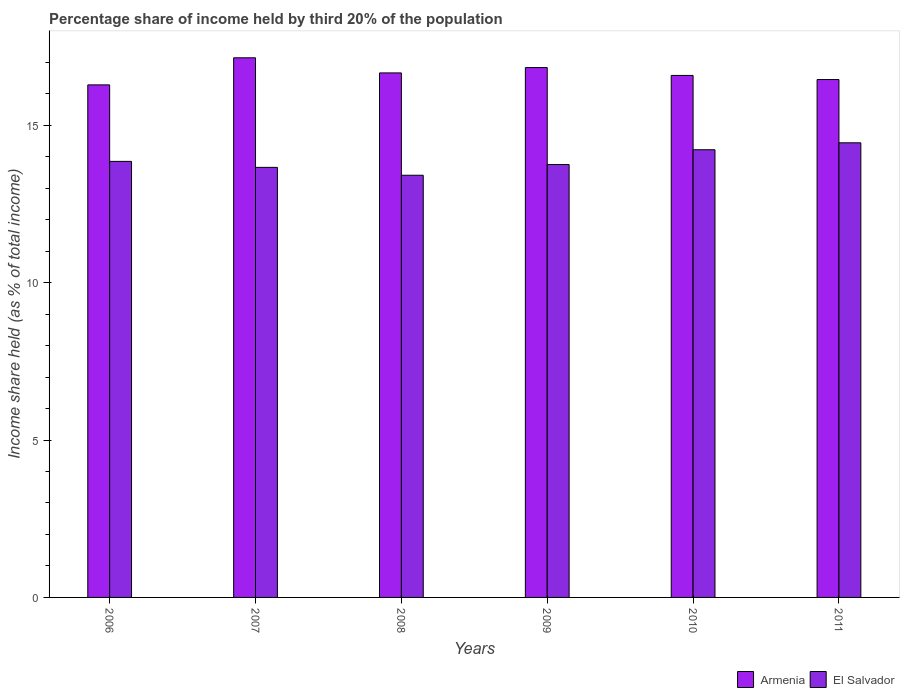Are the number of bars on each tick of the X-axis equal?
Provide a succinct answer. Yes. How many bars are there on the 4th tick from the left?
Provide a succinct answer. 2. How many bars are there on the 6th tick from the right?
Make the answer very short. 2. What is the label of the 1st group of bars from the left?
Give a very brief answer. 2006. In how many cases, is the number of bars for a given year not equal to the number of legend labels?
Keep it short and to the point. 0. What is the share of income held by third 20% of the population in El Salvador in 2010?
Make the answer very short. 14.22. Across all years, what is the maximum share of income held by third 20% of the population in El Salvador?
Ensure brevity in your answer.  14.44. Across all years, what is the minimum share of income held by third 20% of the population in El Salvador?
Your response must be concise. 13.41. In which year was the share of income held by third 20% of the population in El Salvador maximum?
Your answer should be compact. 2011. In which year was the share of income held by third 20% of the population in Armenia minimum?
Your response must be concise. 2006. What is the total share of income held by third 20% of the population in El Salvador in the graph?
Your response must be concise. 83.33. What is the difference between the share of income held by third 20% of the population in Armenia in 2008 and that in 2009?
Provide a short and direct response. -0.17. What is the difference between the share of income held by third 20% of the population in Armenia in 2008 and the share of income held by third 20% of the population in El Salvador in 2006?
Provide a short and direct response. 2.81. What is the average share of income held by third 20% of the population in Armenia per year?
Ensure brevity in your answer.  16.66. In the year 2007, what is the difference between the share of income held by third 20% of the population in Armenia and share of income held by third 20% of the population in El Salvador?
Provide a short and direct response. 3.48. What is the ratio of the share of income held by third 20% of the population in Armenia in 2008 to that in 2009?
Ensure brevity in your answer.  0.99. Is the share of income held by third 20% of the population in Armenia in 2007 less than that in 2008?
Keep it short and to the point. No. Is the difference between the share of income held by third 20% of the population in Armenia in 2006 and 2011 greater than the difference between the share of income held by third 20% of the population in El Salvador in 2006 and 2011?
Your answer should be compact. Yes. What is the difference between the highest and the second highest share of income held by third 20% of the population in El Salvador?
Give a very brief answer. 0.22. What is the difference between the highest and the lowest share of income held by third 20% of the population in El Salvador?
Your answer should be very brief. 1.03. In how many years, is the share of income held by third 20% of the population in El Salvador greater than the average share of income held by third 20% of the population in El Salvador taken over all years?
Your response must be concise. 2. Is the sum of the share of income held by third 20% of the population in Armenia in 2006 and 2007 greater than the maximum share of income held by third 20% of the population in El Salvador across all years?
Your response must be concise. Yes. What does the 1st bar from the left in 2011 represents?
Ensure brevity in your answer.  Armenia. What does the 2nd bar from the right in 2009 represents?
Your answer should be compact. Armenia. How many bars are there?
Offer a very short reply. 12. Are all the bars in the graph horizontal?
Ensure brevity in your answer.  No. How many years are there in the graph?
Your answer should be very brief. 6. What is the difference between two consecutive major ticks on the Y-axis?
Your answer should be very brief. 5. Does the graph contain any zero values?
Make the answer very short. No. How many legend labels are there?
Offer a terse response. 2. How are the legend labels stacked?
Your answer should be compact. Horizontal. What is the title of the graph?
Give a very brief answer. Percentage share of income held by third 20% of the population. Does "Virgin Islands" appear as one of the legend labels in the graph?
Offer a terse response. No. What is the label or title of the X-axis?
Your response must be concise. Years. What is the label or title of the Y-axis?
Ensure brevity in your answer.  Income share held (as % of total income). What is the Income share held (as % of total income) in Armenia in 2006?
Offer a very short reply. 16.28. What is the Income share held (as % of total income) in El Salvador in 2006?
Your answer should be compact. 13.85. What is the Income share held (as % of total income) in Armenia in 2007?
Offer a terse response. 17.14. What is the Income share held (as % of total income) of El Salvador in 2007?
Your answer should be very brief. 13.66. What is the Income share held (as % of total income) in Armenia in 2008?
Ensure brevity in your answer.  16.66. What is the Income share held (as % of total income) of El Salvador in 2008?
Your answer should be compact. 13.41. What is the Income share held (as % of total income) of Armenia in 2009?
Give a very brief answer. 16.83. What is the Income share held (as % of total income) in El Salvador in 2009?
Provide a short and direct response. 13.75. What is the Income share held (as % of total income) in Armenia in 2010?
Offer a very short reply. 16.58. What is the Income share held (as % of total income) of El Salvador in 2010?
Your answer should be very brief. 14.22. What is the Income share held (as % of total income) of Armenia in 2011?
Keep it short and to the point. 16.45. What is the Income share held (as % of total income) of El Salvador in 2011?
Make the answer very short. 14.44. Across all years, what is the maximum Income share held (as % of total income) in Armenia?
Your answer should be very brief. 17.14. Across all years, what is the maximum Income share held (as % of total income) in El Salvador?
Provide a succinct answer. 14.44. Across all years, what is the minimum Income share held (as % of total income) of Armenia?
Offer a terse response. 16.28. Across all years, what is the minimum Income share held (as % of total income) in El Salvador?
Your response must be concise. 13.41. What is the total Income share held (as % of total income) in Armenia in the graph?
Provide a short and direct response. 99.94. What is the total Income share held (as % of total income) of El Salvador in the graph?
Provide a succinct answer. 83.33. What is the difference between the Income share held (as % of total income) in Armenia in 2006 and that in 2007?
Offer a very short reply. -0.86. What is the difference between the Income share held (as % of total income) of El Salvador in 2006 and that in 2007?
Give a very brief answer. 0.19. What is the difference between the Income share held (as % of total income) of Armenia in 2006 and that in 2008?
Provide a succinct answer. -0.38. What is the difference between the Income share held (as % of total income) of El Salvador in 2006 and that in 2008?
Give a very brief answer. 0.44. What is the difference between the Income share held (as % of total income) in Armenia in 2006 and that in 2009?
Your answer should be very brief. -0.55. What is the difference between the Income share held (as % of total income) of El Salvador in 2006 and that in 2009?
Your response must be concise. 0.1. What is the difference between the Income share held (as % of total income) in Armenia in 2006 and that in 2010?
Your response must be concise. -0.3. What is the difference between the Income share held (as % of total income) of El Salvador in 2006 and that in 2010?
Offer a terse response. -0.37. What is the difference between the Income share held (as % of total income) in Armenia in 2006 and that in 2011?
Make the answer very short. -0.17. What is the difference between the Income share held (as % of total income) in El Salvador in 2006 and that in 2011?
Offer a very short reply. -0.59. What is the difference between the Income share held (as % of total income) in Armenia in 2007 and that in 2008?
Offer a terse response. 0.48. What is the difference between the Income share held (as % of total income) in Armenia in 2007 and that in 2009?
Make the answer very short. 0.31. What is the difference between the Income share held (as % of total income) of El Salvador in 2007 and that in 2009?
Make the answer very short. -0.09. What is the difference between the Income share held (as % of total income) in Armenia in 2007 and that in 2010?
Provide a succinct answer. 0.56. What is the difference between the Income share held (as % of total income) of El Salvador in 2007 and that in 2010?
Give a very brief answer. -0.56. What is the difference between the Income share held (as % of total income) in Armenia in 2007 and that in 2011?
Offer a terse response. 0.69. What is the difference between the Income share held (as % of total income) in El Salvador in 2007 and that in 2011?
Provide a succinct answer. -0.78. What is the difference between the Income share held (as % of total income) of Armenia in 2008 and that in 2009?
Your answer should be compact. -0.17. What is the difference between the Income share held (as % of total income) in El Salvador in 2008 and that in 2009?
Your answer should be very brief. -0.34. What is the difference between the Income share held (as % of total income) of Armenia in 2008 and that in 2010?
Your response must be concise. 0.08. What is the difference between the Income share held (as % of total income) in El Salvador in 2008 and that in 2010?
Offer a very short reply. -0.81. What is the difference between the Income share held (as % of total income) of Armenia in 2008 and that in 2011?
Offer a terse response. 0.21. What is the difference between the Income share held (as % of total income) in El Salvador in 2008 and that in 2011?
Your answer should be very brief. -1.03. What is the difference between the Income share held (as % of total income) in El Salvador in 2009 and that in 2010?
Provide a succinct answer. -0.47. What is the difference between the Income share held (as % of total income) in Armenia in 2009 and that in 2011?
Make the answer very short. 0.38. What is the difference between the Income share held (as % of total income) of El Salvador in 2009 and that in 2011?
Provide a succinct answer. -0.69. What is the difference between the Income share held (as % of total income) in Armenia in 2010 and that in 2011?
Your answer should be compact. 0.13. What is the difference between the Income share held (as % of total income) of El Salvador in 2010 and that in 2011?
Your answer should be very brief. -0.22. What is the difference between the Income share held (as % of total income) of Armenia in 2006 and the Income share held (as % of total income) of El Salvador in 2007?
Offer a very short reply. 2.62. What is the difference between the Income share held (as % of total income) in Armenia in 2006 and the Income share held (as % of total income) in El Salvador in 2008?
Provide a succinct answer. 2.87. What is the difference between the Income share held (as % of total income) in Armenia in 2006 and the Income share held (as % of total income) in El Salvador in 2009?
Provide a short and direct response. 2.53. What is the difference between the Income share held (as % of total income) of Armenia in 2006 and the Income share held (as % of total income) of El Salvador in 2010?
Offer a terse response. 2.06. What is the difference between the Income share held (as % of total income) in Armenia in 2006 and the Income share held (as % of total income) in El Salvador in 2011?
Give a very brief answer. 1.84. What is the difference between the Income share held (as % of total income) in Armenia in 2007 and the Income share held (as % of total income) in El Salvador in 2008?
Ensure brevity in your answer.  3.73. What is the difference between the Income share held (as % of total income) in Armenia in 2007 and the Income share held (as % of total income) in El Salvador in 2009?
Ensure brevity in your answer.  3.39. What is the difference between the Income share held (as % of total income) of Armenia in 2007 and the Income share held (as % of total income) of El Salvador in 2010?
Your answer should be very brief. 2.92. What is the difference between the Income share held (as % of total income) in Armenia in 2007 and the Income share held (as % of total income) in El Salvador in 2011?
Your response must be concise. 2.7. What is the difference between the Income share held (as % of total income) in Armenia in 2008 and the Income share held (as % of total income) in El Salvador in 2009?
Keep it short and to the point. 2.91. What is the difference between the Income share held (as % of total income) in Armenia in 2008 and the Income share held (as % of total income) in El Salvador in 2010?
Your answer should be very brief. 2.44. What is the difference between the Income share held (as % of total income) in Armenia in 2008 and the Income share held (as % of total income) in El Salvador in 2011?
Offer a very short reply. 2.22. What is the difference between the Income share held (as % of total income) in Armenia in 2009 and the Income share held (as % of total income) in El Salvador in 2010?
Your answer should be compact. 2.61. What is the difference between the Income share held (as % of total income) of Armenia in 2009 and the Income share held (as % of total income) of El Salvador in 2011?
Your answer should be very brief. 2.39. What is the difference between the Income share held (as % of total income) in Armenia in 2010 and the Income share held (as % of total income) in El Salvador in 2011?
Your response must be concise. 2.14. What is the average Income share held (as % of total income) in Armenia per year?
Offer a terse response. 16.66. What is the average Income share held (as % of total income) of El Salvador per year?
Provide a short and direct response. 13.89. In the year 2006, what is the difference between the Income share held (as % of total income) in Armenia and Income share held (as % of total income) in El Salvador?
Keep it short and to the point. 2.43. In the year 2007, what is the difference between the Income share held (as % of total income) of Armenia and Income share held (as % of total income) of El Salvador?
Offer a terse response. 3.48. In the year 2008, what is the difference between the Income share held (as % of total income) of Armenia and Income share held (as % of total income) of El Salvador?
Offer a terse response. 3.25. In the year 2009, what is the difference between the Income share held (as % of total income) of Armenia and Income share held (as % of total income) of El Salvador?
Keep it short and to the point. 3.08. In the year 2010, what is the difference between the Income share held (as % of total income) of Armenia and Income share held (as % of total income) of El Salvador?
Ensure brevity in your answer.  2.36. In the year 2011, what is the difference between the Income share held (as % of total income) of Armenia and Income share held (as % of total income) of El Salvador?
Provide a succinct answer. 2.01. What is the ratio of the Income share held (as % of total income) in Armenia in 2006 to that in 2007?
Offer a very short reply. 0.95. What is the ratio of the Income share held (as % of total income) in El Salvador in 2006 to that in 2007?
Offer a very short reply. 1.01. What is the ratio of the Income share held (as % of total income) of Armenia in 2006 to that in 2008?
Your answer should be very brief. 0.98. What is the ratio of the Income share held (as % of total income) in El Salvador in 2006 to that in 2008?
Give a very brief answer. 1.03. What is the ratio of the Income share held (as % of total income) in Armenia in 2006 to that in 2009?
Keep it short and to the point. 0.97. What is the ratio of the Income share held (as % of total income) of El Salvador in 2006 to that in 2009?
Provide a succinct answer. 1.01. What is the ratio of the Income share held (as % of total income) in Armenia in 2006 to that in 2010?
Keep it short and to the point. 0.98. What is the ratio of the Income share held (as % of total income) of El Salvador in 2006 to that in 2010?
Provide a short and direct response. 0.97. What is the ratio of the Income share held (as % of total income) of Armenia in 2006 to that in 2011?
Provide a short and direct response. 0.99. What is the ratio of the Income share held (as % of total income) in El Salvador in 2006 to that in 2011?
Offer a very short reply. 0.96. What is the ratio of the Income share held (as % of total income) in Armenia in 2007 to that in 2008?
Your answer should be compact. 1.03. What is the ratio of the Income share held (as % of total income) in El Salvador in 2007 to that in 2008?
Your answer should be very brief. 1.02. What is the ratio of the Income share held (as % of total income) in Armenia in 2007 to that in 2009?
Provide a succinct answer. 1.02. What is the ratio of the Income share held (as % of total income) of El Salvador in 2007 to that in 2009?
Provide a short and direct response. 0.99. What is the ratio of the Income share held (as % of total income) in Armenia in 2007 to that in 2010?
Offer a terse response. 1.03. What is the ratio of the Income share held (as % of total income) in El Salvador in 2007 to that in 2010?
Make the answer very short. 0.96. What is the ratio of the Income share held (as % of total income) of Armenia in 2007 to that in 2011?
Provide a short and direct response. 1.04. What is the ratio of the Income share held (as % of total income) in El Salvador in 2007 to that in 2011?
Your response must be concise. 0.95. What is the ratio of the Income share held (as % of total income) of El Salvador in 2008 to that in 2009?
Keep it short and to the point. 0.98. What is the ratio of the Income share held (as % of total income) of El Salvador in 2008 to that in 2010?
Keep it short and to the point. 0.94. What is the ratio of the Income share held (as % of total income) in Armenia in 2008 to that in 2011?
Offer a terse response. 1.01. What is the ratio of the Income share held (as % of total income) of El Salvador in 2008 to that in 2011?
Give a very brief answer. 0.93. What is the ratio of the Income share held (as % of total income) of Armenia in 2009 to that in 2010?
Provide a succinct answer. 1.02. What is the ratio of the Income share held (as % of total income) of El Salvador in 2009 to that in 2010?
Your answer should be very brief. 0.97. What is the ratio of the Income share held (as % of total income) in Armenia in 2009 to that in 2011?
Ensure brevity in your answer.  1.02. What is the ratio of the Income share held (as % of total income) in El Salvador in 2009 to that in 2011?
Provide a succinct answer. 0.95. What is the ratio of the Income share held (as % of total income) of Armenia in 2010 to that in 2011?
Your answer should be very brief. 1.01. What is the ratio of the Income share held (as % of total income) of El Salvador in 2010 to that in 2011?
Provide a short and direct response. 0.98. What is the difference between the highest and the second highest Income share held (as % of total income) of Armenia?
Ensure brevity in your answer.  0.31. What is the difference between the highest and the second highest Income share held (as % of total income) in El Salvador?
Provide a short and direct response. 0.22. What is the difference between the highest and the lowest Income share held (as % of total income) in Armenia?
Offer a very short reply. 0.86. What is the difference between the highest and the lowest Income share held (as % of total income) in El Salvador?
Your response must be concise. 1.03. 